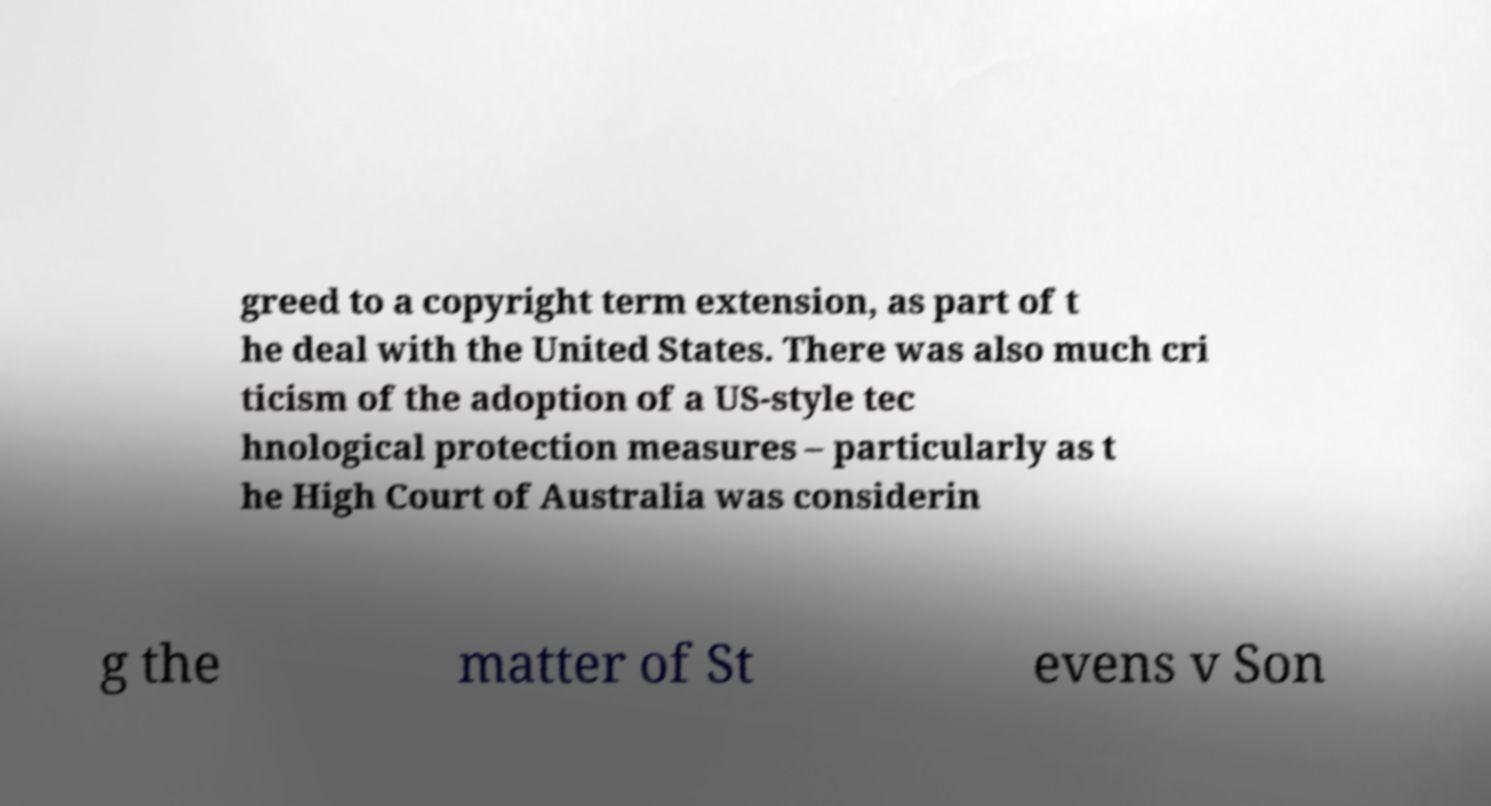Can you accurately transcribe the text from the provided image for me? greed to a copyright term extension, as part of t he deal with the United States. There was also much cri ticism of the adoption of a US-style tec hnological protection measures – particularly as t he High Court of Australia was considerin g the matter of St evens v Son 